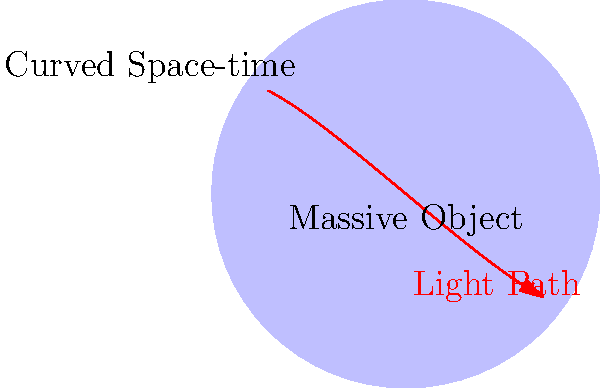In the diagram, a light ray is shown passing near a massive object. How does the curvature of space-time affect the path of the light, and what physical phenomenon does this demonstrate? To understand this phenomenon, let's break it down step-by-step:

1. According to Einstein's theory of General Relativity, massive objects curve space-time around them.

2. Light always travels along the shortest path between two points, which we call a geodesic.

3. In flat space-time, this geodesic would be a straight line. However, near massive objects, space-time is curved.

4. As a result, the geodesic that light follows appears curved from our perspective.

5. This curving of light's path due to the warping of space-time is called gravitational lensing.

6. The amount of deflection depends on the mass of the object and how close the light passes to it. The more massive the object or the closer the light passes, the greater the deflection.

7. This effect can be observed in astronomical phenomena, such as when light from distant galaxies is bent around massive objects like galaxy clusters, creating multiple or distorted images of the source.

8. In extreme cases, like near black holes, light can be bent so much that it orbits the object, creating what's known as an Einstein ring.

This phenomenon demonstrates that gravity is not a force acting on objects, but rather a consequence of the geometry of space-time itself, which is a fundamental principle of General Relativity.
Answer: Gravitational lensing 